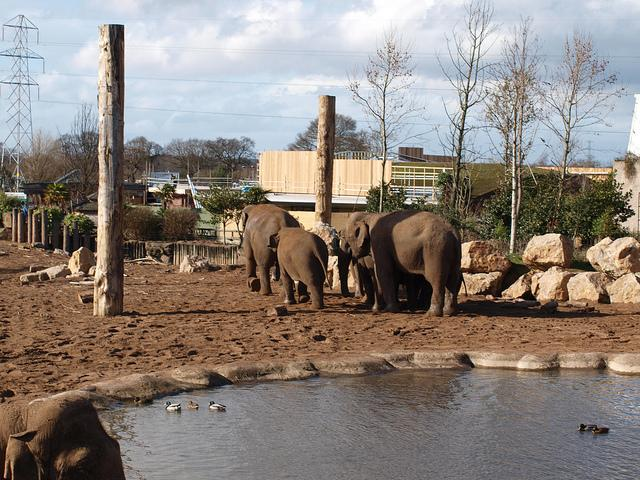What body of water is this? Please explain your reasoning. pond. Elephants are near a small body of water with ducks in it. 